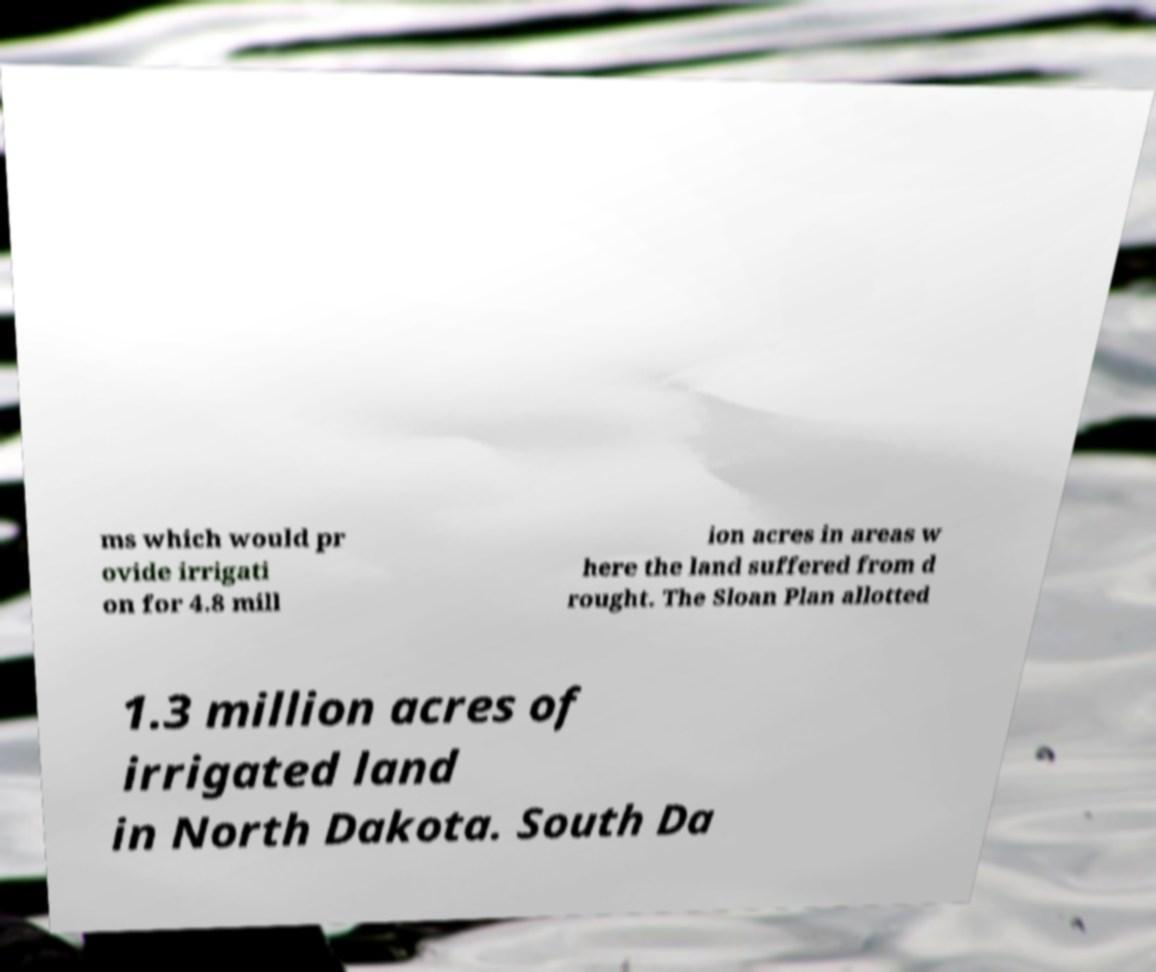Can you read and provide the text displayed in the image?This photo seems to have some interesting text. Can you extract and type it out for me? ms which would pr ovide irrigati on for 4.8 mill ion acres in areas w here the land suffered from d rought. The Sloan Plan allotted 1.3 million acres of irrigated land in North Dakota. South Da 